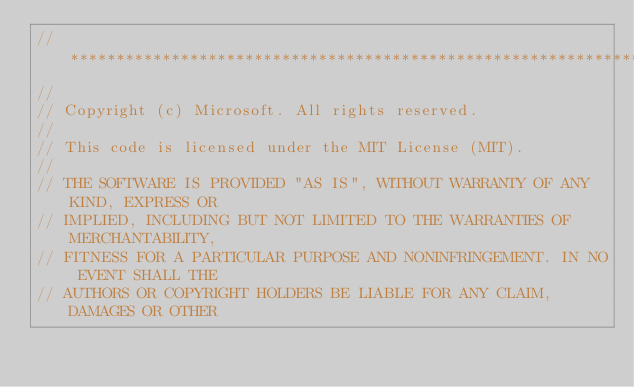Convert code to text. <code><loc_0><loc_0><loc_500><loc_500><_ObjectiveC_>//******************************************************************************
//
// Copyright (c) Microsoft. All rights reserved.
//
// This code is licensed under the MIT License (MIT).
//
// THE SOFTWARE IS PROVIDED "AS IS", WITHOUT WARRANTY OF ANY KIND, EXPRESS OR
// IMPLIED, INCLUDING BUT NOT LIMITED TO THE WARRANTIES OF MERCHANTABILITY,
// FITNESS FOR A PARTICULAR PURPOSE AND NONINFRINGEMENT. IN NO EVENT SHALL THE
// AUTHORS OR COPYRIGHT HOLDERS BE LIABLE FOR ANY CLAIM, DAMAGES OR OTHER</code> 